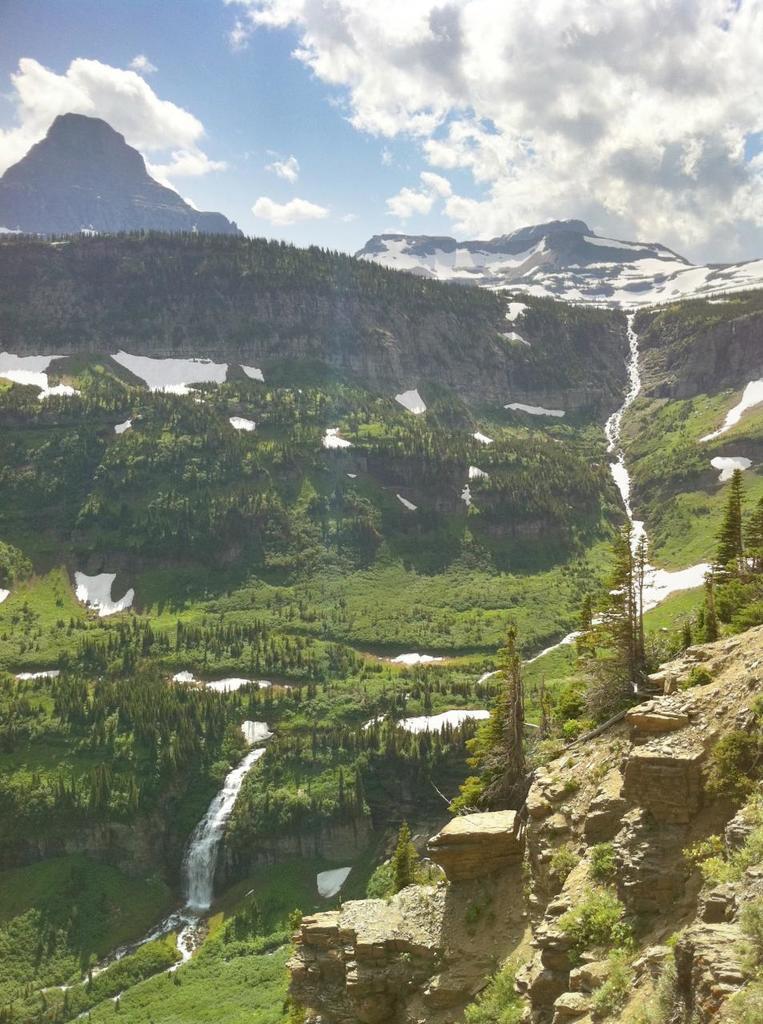Describe this image in one or two sentences. In this image at the bottom, there are stones, trees, water falls, water, grass. At the top there are hills, trees, ice, grass, sky and clouds. 